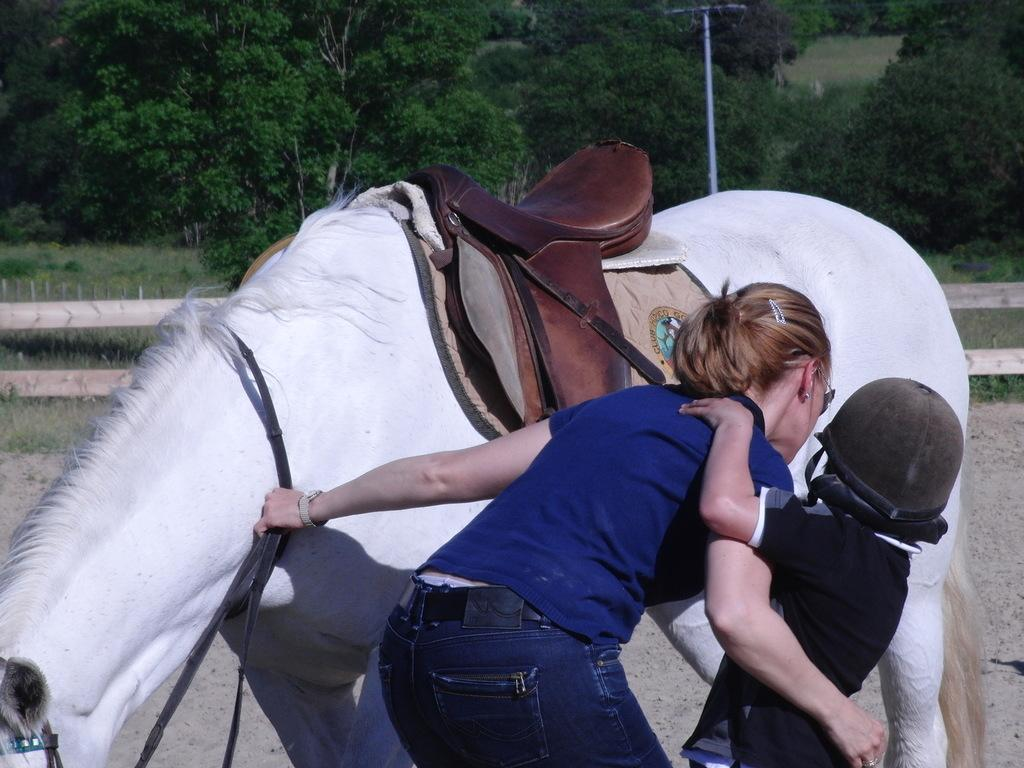What type of animal is in the image? There is a white horse in the image. Who else is present in the image besides the horse? There is a woman and a kid in the image. What is the woman wearing? The woman is wearing a blue t-shirt. What is the kid wearing that provides protection? The kid is wearing a helmet. What can be seen in the background of the image? There are trees in the background of the image. What type of support can be seen in the image for the horse to stand on? There is no support for the horse to stand on in the image; the horse is standing on the ground. Can you find the receipt for the horse in the image? There is no receipt present in the image. 